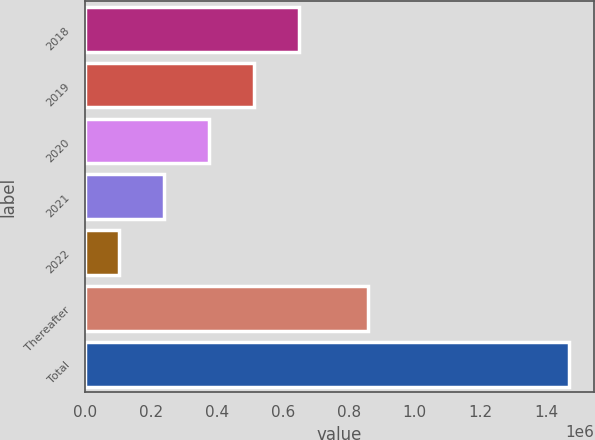Convert chart to OTSL. <chart><loc_0><loc_0><loc_500><loc_500><bar_chart><fcel>2018<fcel>2019<fcel>2020<fcel>2021<fcel>2022<fcel>Thereafter<fcel>Total<nl><fcel>649186<fcel>512611<fcel>376035<fcel>239460<fcel>102884<fcel>857454<fcel>1.46864e+06<nl></chart> 